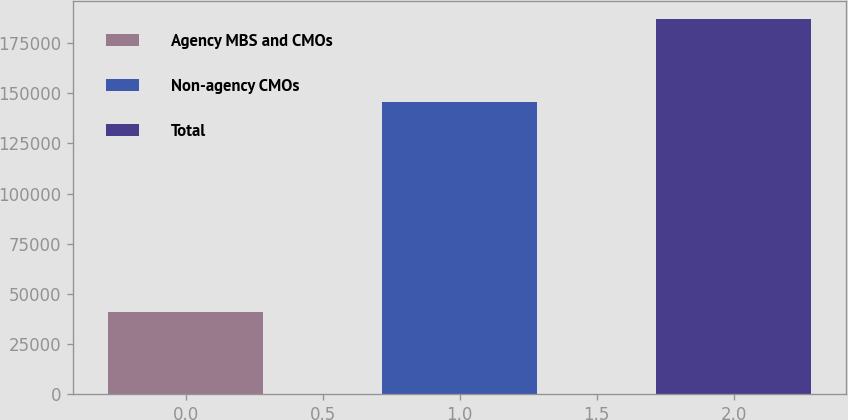Convert chart. <chart><loc_0><loc_0><loc_500><loc_500><bar_chart><fcel>Agency MBS and CMOs<fcel>Non-agency CMOs<fcel>Total<nl><fcel>41068<fcel>145875<fcel>186943<nl></chart> 